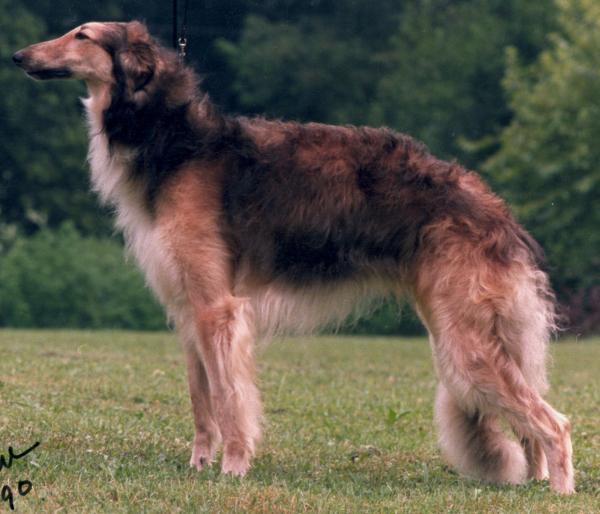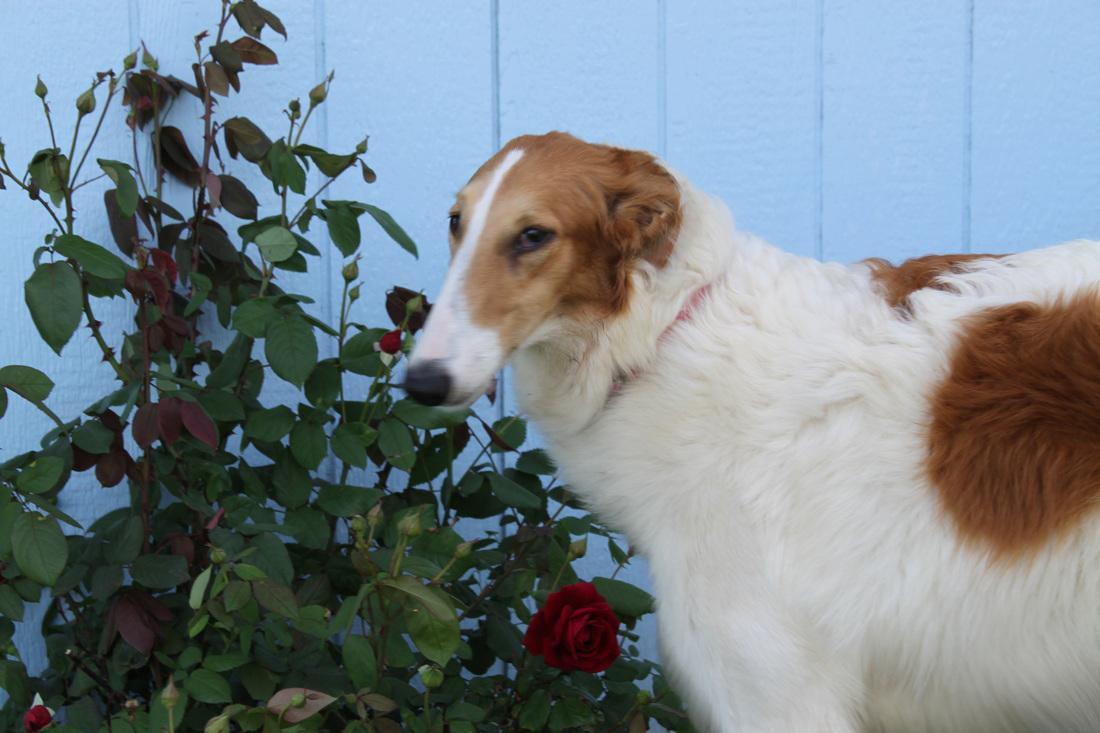The first image is the image on the left, the second image is the image on the right. Analyze the images presented: Is the assertion "One dog's mouth is open and the other dog's mouth is closed." valid? Answer yes or no. No. The first image is the image on the left, the second image is the image on the right. For the images shown, is this caption "All dogs are orange-and-white hounds standing with their bodies turned to the left, but one dog is looking back over its shoulder." true? Answer yes or no. No. 